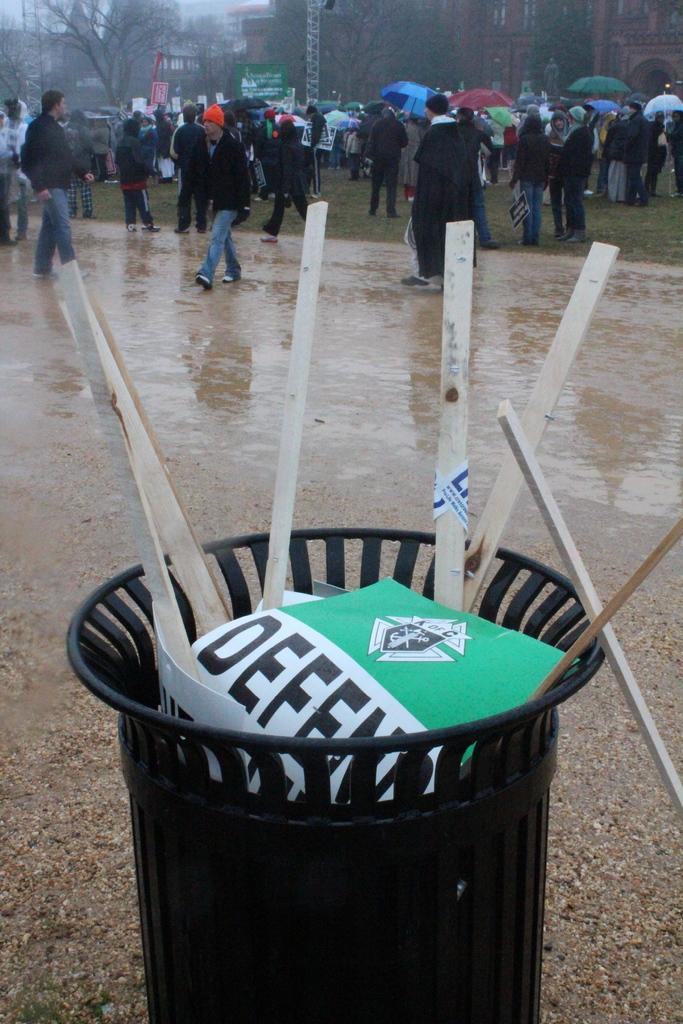<image>
Relay a brief, clear account of the picture shown. A bunch of DEFEAT signs were thrown away in a trash bin by a group of people. 